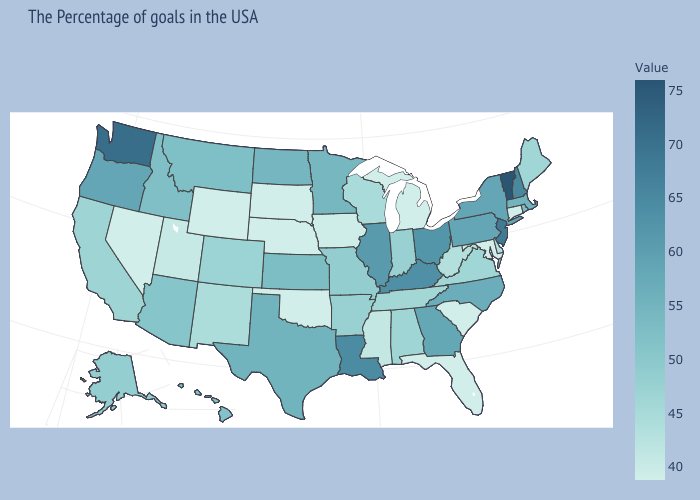Does Washington have the highest value in the West?
Give a very brief answer. Yes. Which states have the lowest value in the USA?
Write a very short answer. Connecticut, Maryland, South Carolina, Florida, Michigan, Nebraska, Oklahoma, South Dakota, Wyoming, Nevada. Among the states that border South Dakota , which have the lowest value?
Quick response, please. Nebraska, Wyoming. Does the map have missing data?
Answer briefly. No. 